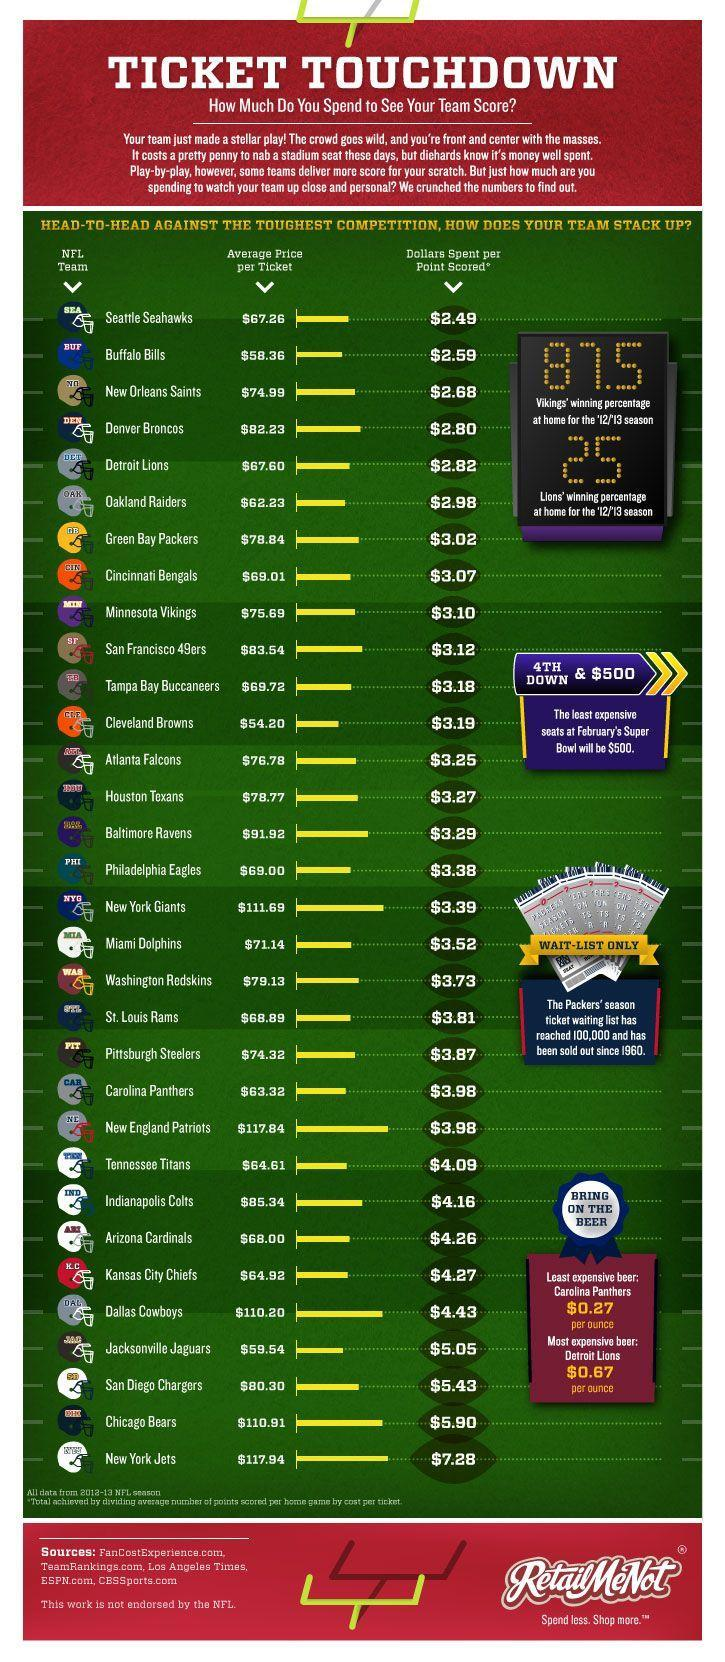Which team has the lowest average price per ticket?
Answer the question with a short phrase. Cleveland Browns What is the price of the least expensive beer? $0.27 Which team has the second highest average price per ticket? New England Patriots What is the price of the most expensive beer? $0.67 